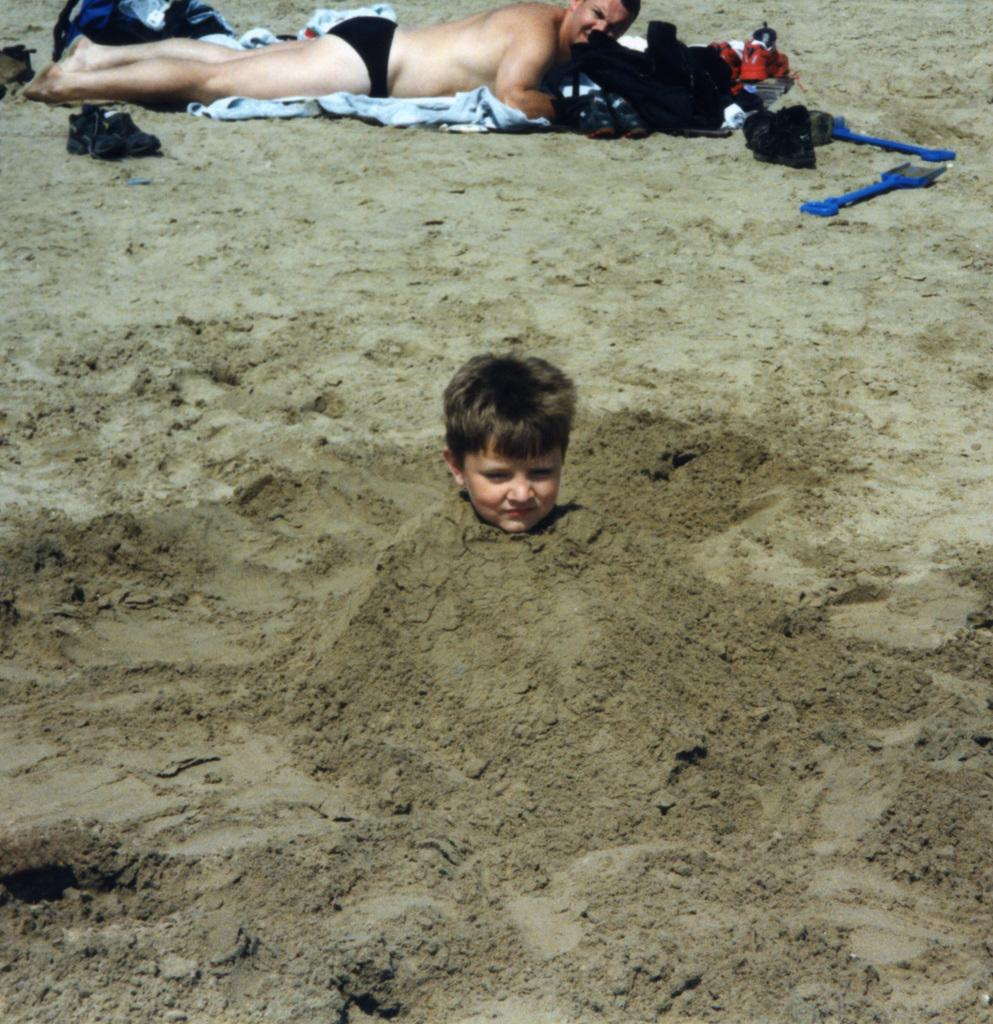Who is the main subject in the image? There is a boy in the image. What is the boy's current situation? The boy is in mud. What is the person lying on in the image? The person is lying on a cloth in the image. Where is the cloth located? The cloth is on the land. What can be seen on the boy's feet? There are shoes visible in the image. What other objects are present on the land? There are other objects on the land, but their specific details are not mentioned in the facts. What type of fork can be seen in the image? There is no fork present in the image. How many worms are visible in the image? There are no worms visible in the image. 